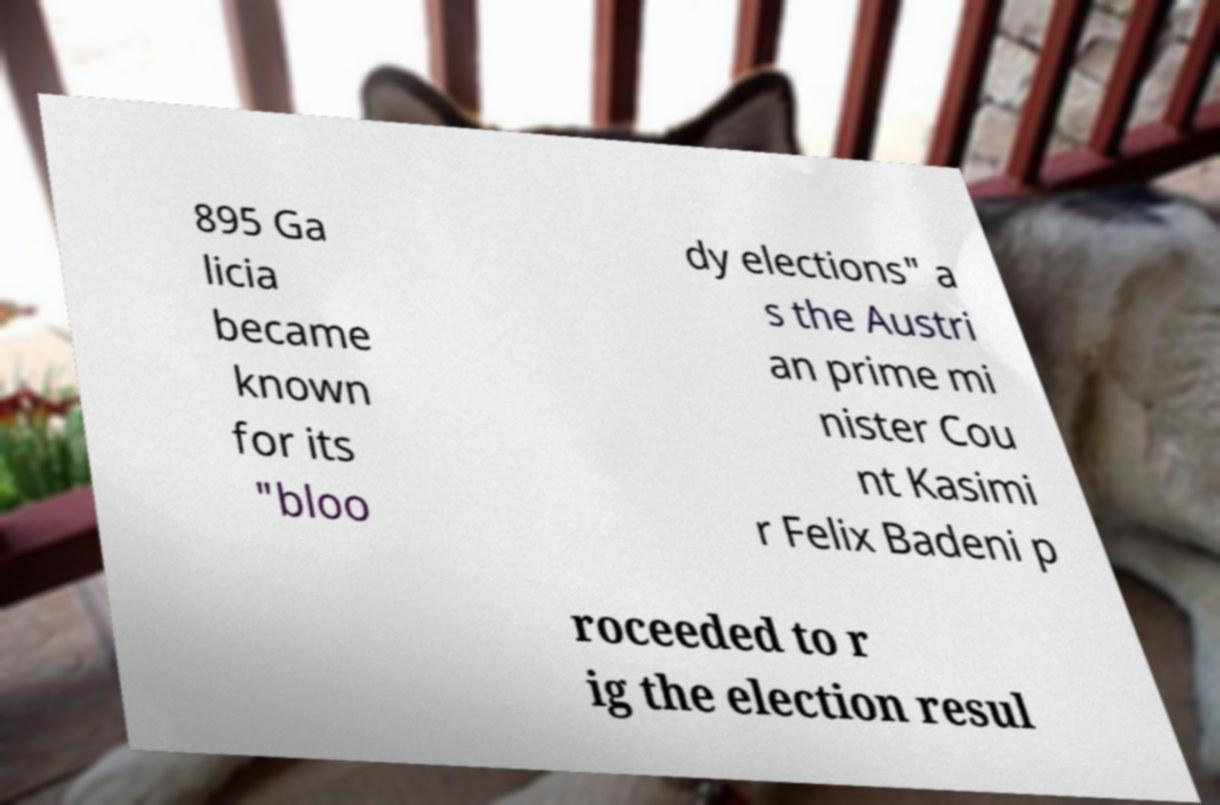Can you accurately transcribe the text from the provided image for me? 895 Ga licia became known for its "bloo dy elections" a s the Austri an prime mi nister Cou nt Kasimi r Felix Badeni p roceeded to r ig the election resul 